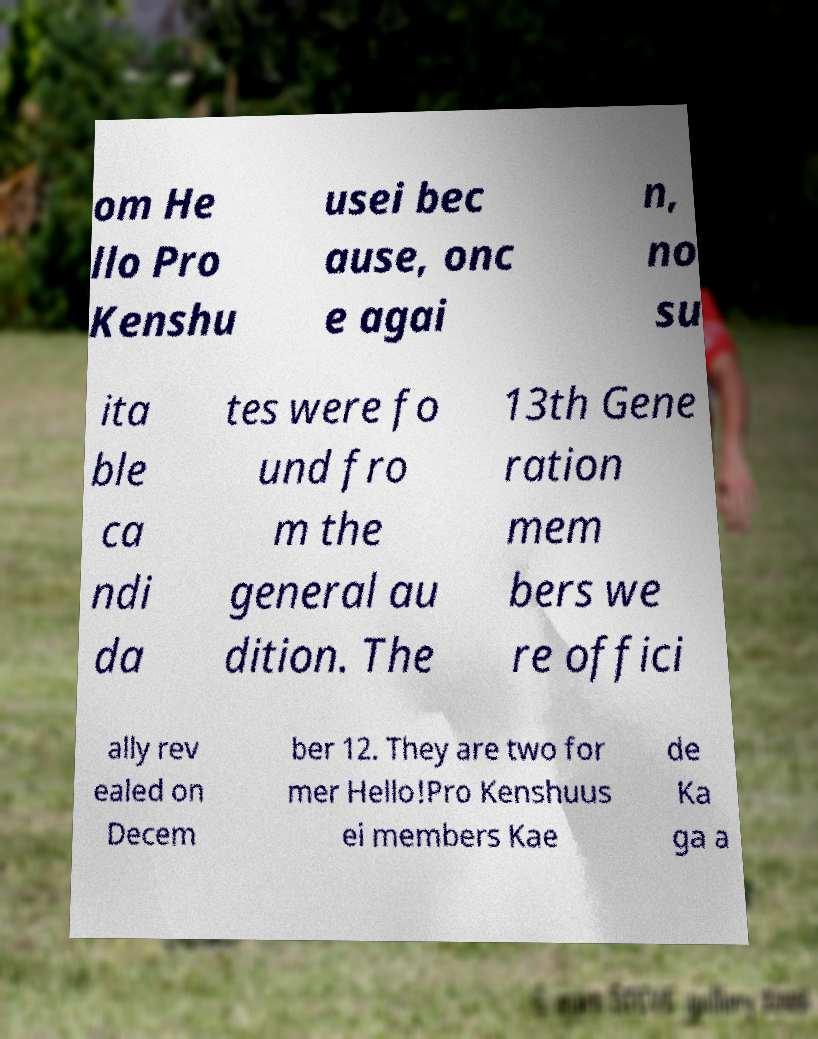Could you extract and type out the text from this image? om He llo Pro Kenshu usei bec ause, onc e agai n, no su ita ble ca ndi da tes were fo und fro m the general au dition. The 13th Gene ration mem bers we re offici ally rev ealed on Decem ber 12. They are two for mer Hello!Pro Kenshuus ei members Kae de Ka ga a 